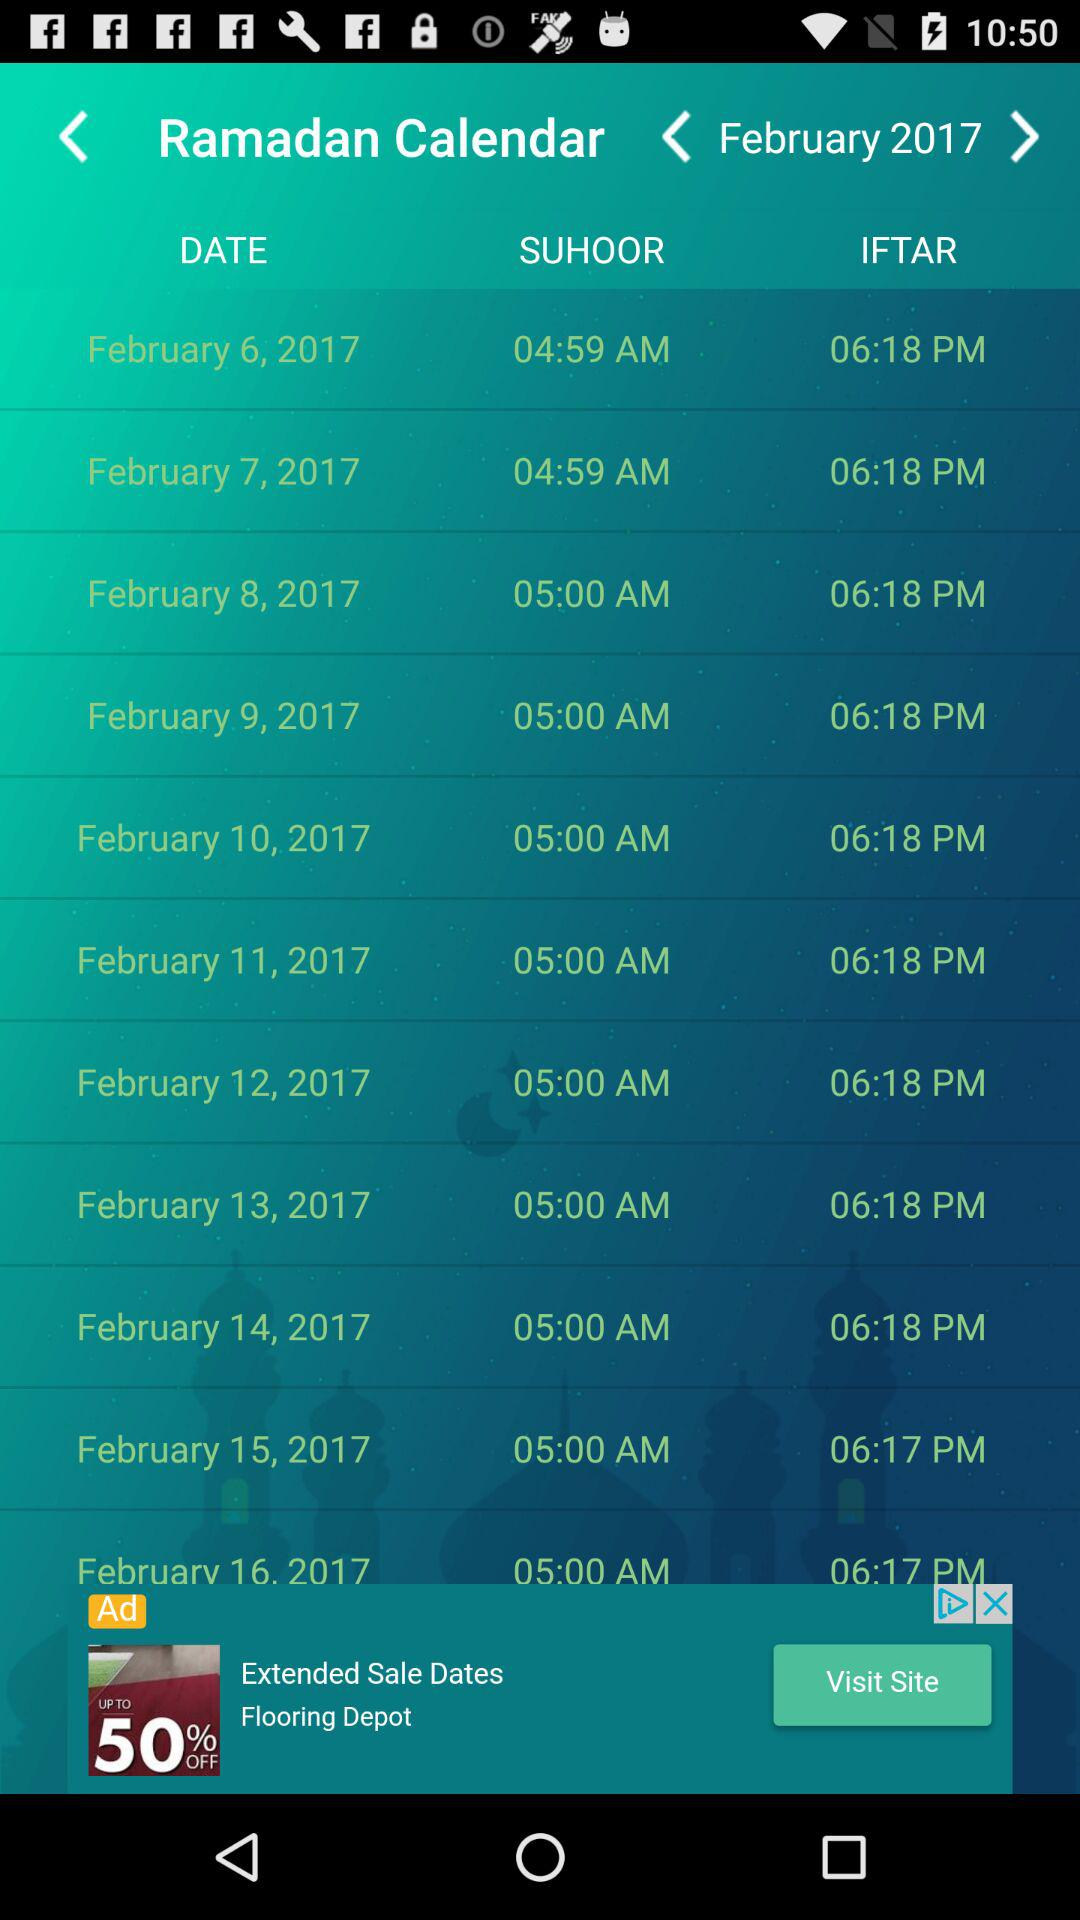What is the name of the calendar? The name of the calendar is "Ramadan Calendar". 